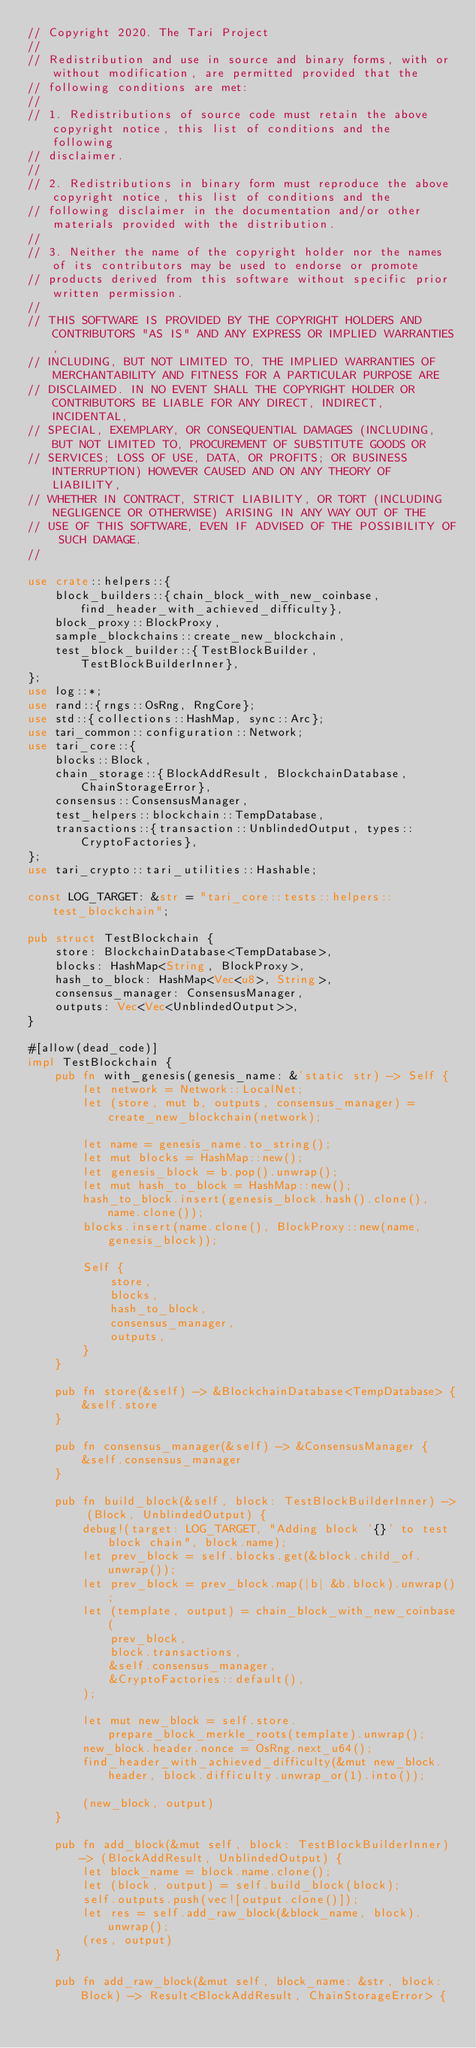Convert code to text. <code><loc_0><loc_0><loc_500><loc_500><_Rust_>// Copyright 2020. The Tari Project
//
// Redistribution and use in source and binary forms, with or without modification, are permitted provided that the
// following conditions are met:
//
// 1. Redistributions of source code must retain the above copyright notice, this list of conditions and the following
// disclaimer.
//
// 2. Redistributions in binary form must reproduce the above copyright notice, this list of conditions and the
// following disclaimer in the documentation and/or other materials provided with the distribution.
//
// 3. Neither the name of the copyright holder nor the names of its contributors may be used to endorse or promote
// products derived from this software without specific prior written permission.
//
// THIS SOFTWARE IS PROVIDED BY THE COPYRIGHT HOLDERS AND CONTRIBUTORS "AS IS" AND ANY EXPRESS OR IMPLIED WARRANTIES,
// INCLUDING, BUT NOT LIMITED TO, THE IMPLIED WARRANTIES OF MERCHANTABILITY AND FITNESS FOR A PARTICULAR PURPOSE ARE
// DISCLAIMED. IN NO EVENT SHALL THE COPYRIGHT HOLDER OR CONTRIBUTORS BE LIABLE FOR ANY DIRECT, INDIRECT, INCIDENTAL,
// SPECIAL, EXEMPLARY, OR CONSEQUENTIAL DAMAGES (INCLUDING, BUT NOT LIMITED TO, PROCUREMENT OF SUBSTITUTE GOODS OR
// SERVICES; LOSS OF USE, DATA, OR PROFITS; OR BUSINESS INTERRUPTION) HOWEVER CAUSED AND ON ANY THEORY OF LIABILITY,
// WHETHER IN CONTRACT, STRICT LIABILITY, OR TORT (INCLUDING NEGLIGENCE OR OTHERWISE) ARISING IN ANY WAY OUT OF THE
// USE OF THIS SOFTWARE, EVEN IF ADVISED OF THE POSSIBILITY OF SUCH DAMAGE.
//

use crate::helpers::{
    block_builders::{chain_block_with_new_coinbase, find_header_with_achieved_difficulty},
    block_proxy::BlockProxy,
    sample_blockchains::create_new_blockchain,
    test_block_builder::{TestBlockBuilder, TestBlockBuilderInner},
};
use log::*;
use rand::{rngs::OsRng, RngCore};
use std::{collections::HashMap, sync::Arc};
use tari_common::configuration::Network;
use tari_core::{
    blocks::Block,
    chain_storage::{BlockAddResult, BlockchainDatabase, ChainStorageError},
    consensus::ConsensusManager,
    test_helpers::blockchain::TempDatabase,
    transactions::{transaction::UnblindedOutput, types::CryptoFactories},
};
use tari_crypto::tari_utilities::Hashable;

const LOG_TARGET: &str = "tari_core::tests::helpers::test_blockchain";

pub struct TestBlockchain {
    store: BlockchainDatabase<TempDatabase>,
    blocks: HashMap<String, BlockProxy>,
    hash_to_block: HashMap<Vec<u8>, String>,
    consensus_manager: ConsensusManager,
    outputs: Vec<Vec<UnblindedOutput>>,
}

#[allow(dead_code)]
impl TestBlockchain {
    pub fn with_genesis(genesis_name: &'static str) -> Self {
        let network = Network::LocalNet;
        let (store, mut b, outputs, consensus_manager) = create_new_blockchain(network);

        let name = genesis_name.to_string();
        let mut blocks = HashMap::new();
        let genesis_block = b.pop().unwrap();
        let mut hash_to_block = HashMap::new();
        hash_to_block.insert(genesis_block.hash().clone(), name.clone());
        blocks.insert(name.clone(), BlockProxy::new(name, genesis_block));

        Self {
            store,
            blocks,
            hash_to_block,
            consensus_manager,
            outputs,
        }
    }

    pub fn store(&self) -> &BlockchainDatabase<TempDatabase> {
        &self.store
    }

    pub fn consensus_manager(&self) -> &ConsensusManager {
        &self.consensus_manager
    }

    pub fn build_block(&self, block: TestBlockBuilderInner) -> (Block, UnblindedOutput) {
        debug!(target: LOG_TARGET, "Adding block '{}' to test block chain", block.name);
        let prev_block = self.blocks.get(&block.child_of.unwrap());
        let prev_block = prev_block.map(|b| &b.block).unwrap();
        let (template, output) = chain_block_with_new_coinbase(
            prev_block,
            block.transactions,
            &self.consensus_manager,
            &CryptoFactories::default(),
        );

        let mut new_block = self.store.prepare_block_merkle_roots(template).unwrap();
        new_block.header.nonce = OsRng.next_u64();
        find_header_with_achieved_difficulty(&mut new_block.header, block.difficulty.unwrap_or(1).into());

        (new_block, output)
    }

    pub fn add_block(&mut self, block: TestBlockBuilderInner) -> (BlockAddResult, UnblindedOutput) {
        let block_name = block.name.clone();
        let (block, output) = self.build_block(block);
        self.outputs.push(vec![output.clone()]);
        let res = self.add_raw_block(&block_name, block).unwrap();
        (res, output)
    }

    pub fn add_raw_block(&mut self, block_name: &str, block: Block) -> Result<BlockAddResult, ChainStorageError> {</code> 